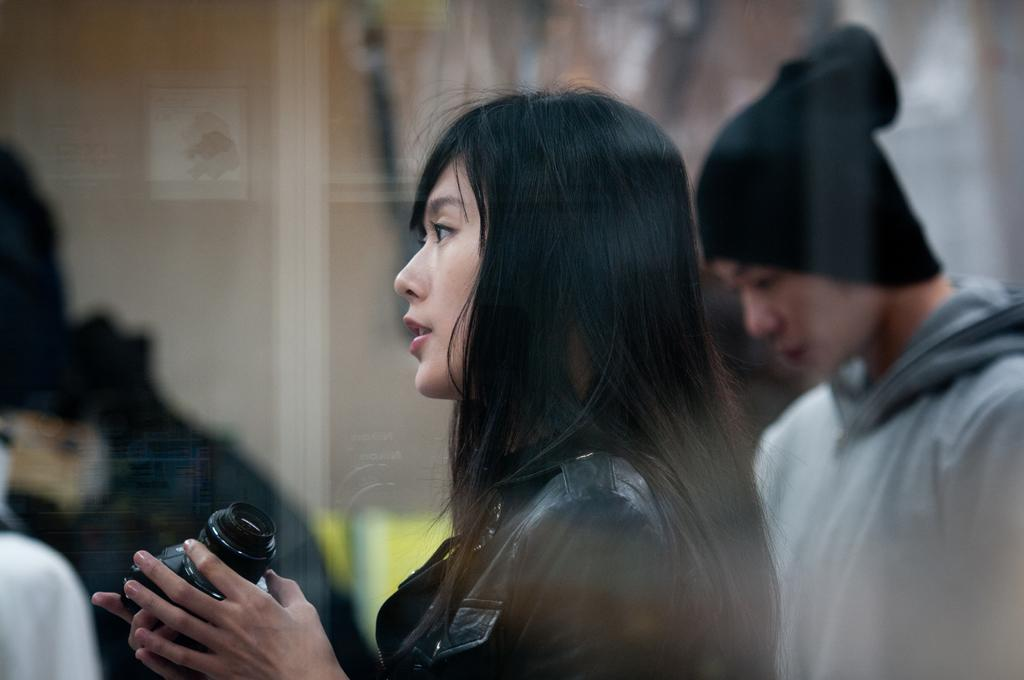Who is the main subject in the image? There is a woman in the image. Can you describe the woman's appearance? The woman has black, long hair. What is the woman holding in her hands? The woman is holding a camera in her hands. Who else is present in the image? There is a man in the image. Can you describe the man's appearance? The man is wearing a black cap. What is the man doing in the image? The man is standing. What sign is the woman using to communicate with the man in the image? There is no sign visible in the image, and the woman is holding a camera, not communicating with the man. 